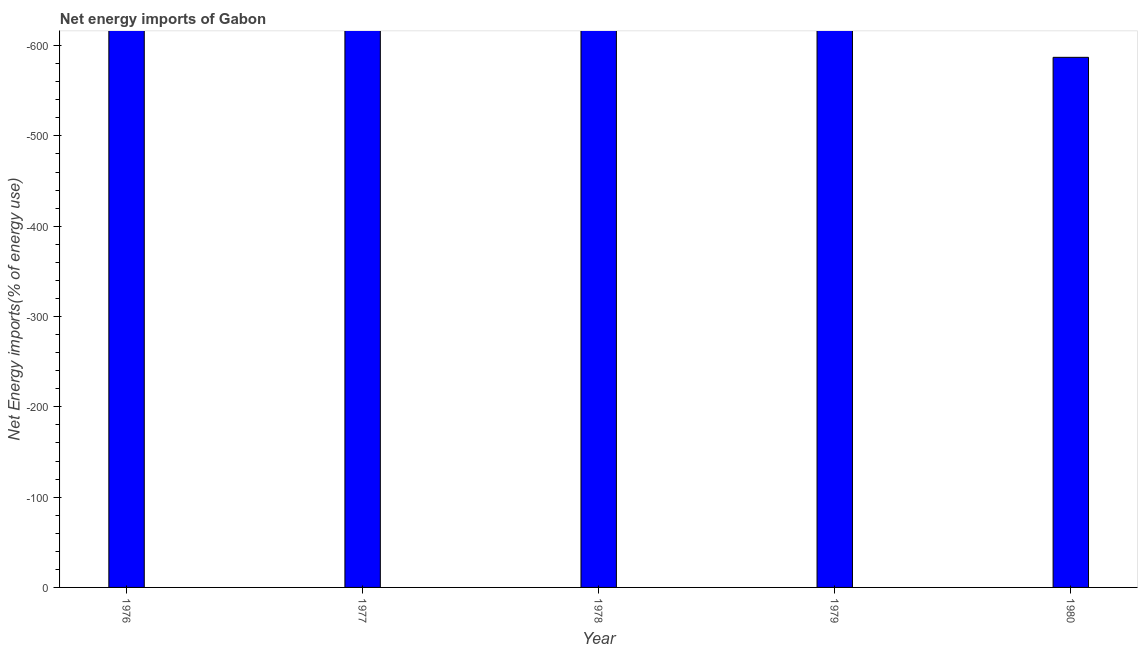Does the graph contain any zero values?
Provide a succinct answer. Yes. What is the title of the graph?
Make the answer very short. Net energy imports of Gabon. What is the label or title of the X-axis?
Your response must be concise. Year. What is the label or title of the Y-axis?
Your answer should be compact. Net Energy imports(% of energy use). What is the energy imports in 1976?
Offer a very short reply. 0. Across all years, what is the minimum energy imports?
Offer a very short reply. 0. What is the sum of the energy imports?
Make the answer very short. 0. What is the median energy imports?
Keep it short and to the point. 0. In how many years, is the energy imports greater than the average energy imports taken over all years?
Make the answer very short. 0. How many bars are there?
Provide a short and direct response. 0. Are all the bars in the graph horizontal?
Give a very brief answer. No. What is the Net Energy imports(% of energy use) in 1977?
Offer a very short reply. 0. What is the Net Energy imports(% of energy use) of 1978?
Offer a terse response. 0. What is the Net Energy imports(% of energy use) in 1979?
Provide a short and direct response. 0. What is the Net Energy imports(% of energy use) in 1980?
Your response must be concise. 0. 